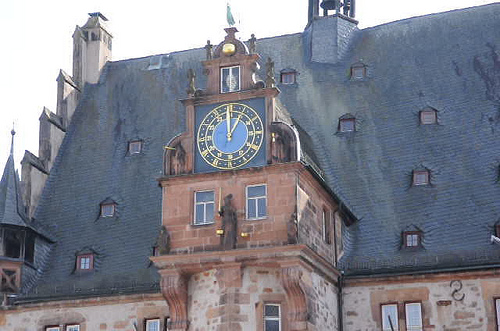Is there any significance to the weather vane design? While the image quality does not allow for a detailed analysis of the weather vane design, such vanes often feature symbolic or locally significant motifs. They can represent the cultural heritage, history, or the crest of the city where the building is located.  Can you identify any distinctive features or decorations on this building? The building displays notable features like the intricate clock face with golden hands and Roman numerals, a small carved figure below the clock, and patterns in the facade that provide a sense of historical elegance and represent the attention to aesthetic detail that was prevalent during the period it was built. 